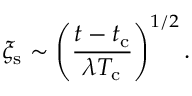<formula> <loc_0><loc_0><loc_500><loc_500>\xi _ { s } \sim \left ( \frac { t - t _ { c } } { \lambda T _ { c } } \right ) ^ { 1 / 2 } .</formula> 